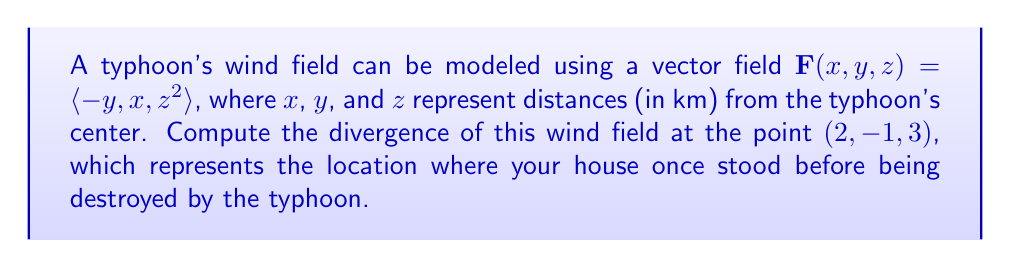What is the answer to this math problem? To solve this problem, we need to follow these steps:

1) The divergence of a vector field $\mathbf{F}(x,y,z) = \langle F_1, F_2, F_3 \rangle$ is given by:

   $$\text{div}\mathbf{F} = \nabla \cdot \mathbf{F} = \frac{\partial F_1}{\partial x} + \frac{\partial F_2}{\partial y} + \frac{\partial F_3}{\partial z}$$

2) In our case, $\mathbf{F}(x,y,z) = \langle -y, x, z^2 \rangle$, so:
   
   $F_1 = -y$
   $F_2 = x$
   $F_3 = z^2$

3) Now, let's calculate each partial derivative:

   $\frac{\partial F_1}{\partial x} = \frac{\partial (-y)}{\partial x} = 0$
   
   $\frac{\partial F_2}{\partial y} = \frac{\partial x}{\partial y} = 0$
   
   $\frac{\partial F_3}{\partial z} = \frac{\partial (z^2)}{\partial z} = 2z$

4) Substituting these into the divergence formula:

   $$\text{div}\mathbf{F} = 0 + 0 + 2z = 2z$$

5) At the point $(2, -1, 3)$, $z = 3$, so:

   $$\text{div}\mathbf{F}(2, -1, 3) = 2(3) = 6$$

This positive divergence indicates that the wind is spreading out (diverging) at this location, which could contribute to the destructive force experienced at your house's former location.
Answer: The divergence of the wind field at the point $(2, -1, 3)$ is 6 km/s. 